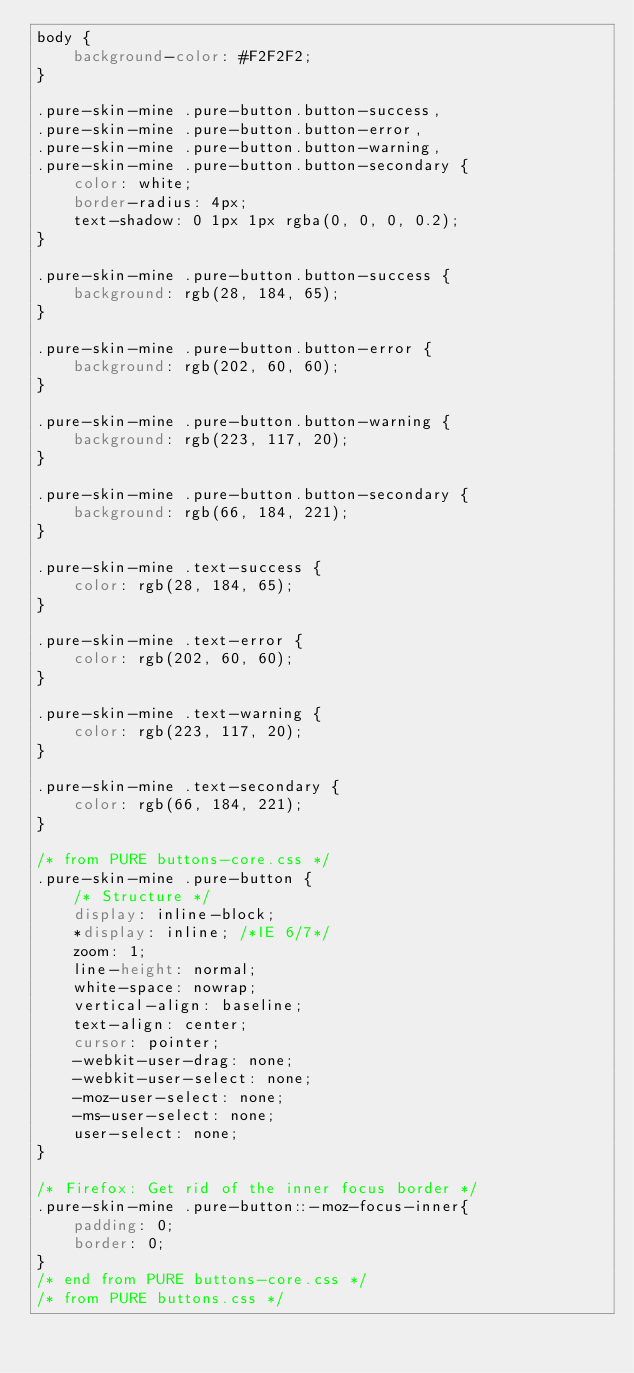Convert code to text. <code><loc_0><loc_0><loc_500><loc_500><_CSS_>body {
    background-color: #F2F2F2;
}

.pure-skin-mine .pure-button.button-success,
.pure-skin-mine .pure-button.button-error,
.pure-skin-mine .pure-button.button-warning,
.pure-skin-mine .pure-button.button-secondary {
    color: white;
    border-radius: 4px;
    text-shadow: 0 1px 1px rgba(0, 0, 0, 0.2);
}

.pure-skin-mine .pure-button.button-success {
    background: rgb(28, 184, 65);
}

.pure-skin-mine .pure-button.button-error {
    background: rgb(202, 60, 60);
}

.pure-skin-mine .pure-button.button-warning {
    background: rgb(223, 117, 20);
}

.pure-skin-mine .pure-button.button-secondary {
    background: rgb(66, 184, 221);
}

.pure-skin-mine .text-success {
    color: rgb(28, 184, 65);
}

.pure-skin-mine .text-error {
    color: rgb(202, 60, 60);
}

.pure-skin-mine .text-warning {
    color: rgb(223, 117, 20);
}

.pure-skin-mine .text-secondary {
    color: rgb(66, 184, 221);
}

/* from PURE buttons-core.css */
.pure-skin-mine .pure-button {
    /* Structure */
    display: inline-block;
    *display: inline; /*IE 6/7*/
    zoom: 1;
    line-height: normal;
    white-space: nowrap;
    vertical-align: baseline;
    text-align: center;
    cursor: pointer;
    -webkit-user-drag: none;
    -webkit-user-select: none;
    -moz-user-select: none;
    -ms-user-select: none;
    user-select: none;
}

/* Firefox: Get rid of the inner focus border */
.pure-skin-mine .pure-button::-moz-focus-inner{
    padding: 0;
    border: 0;
}
/* end from PURE buttons-core.css */
/* from PURE buttons.css */</code> 